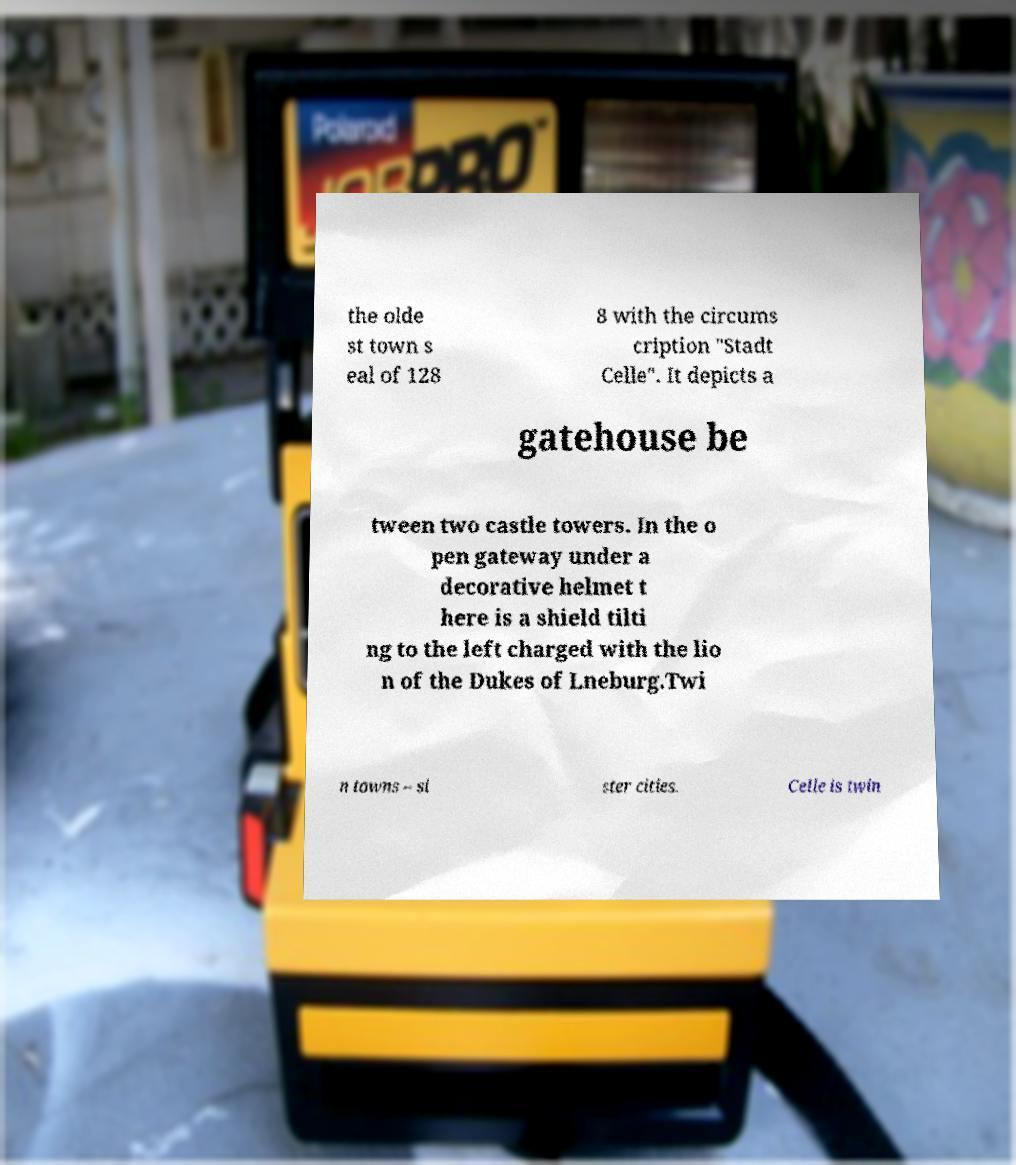For documentation purposes, I need the text within this image transcribed. Could you provide that? the olde st town s eal of 128 8 with the circums cription "Stadt Celle". It depicts a gatehouse be tween two castle towers. In the o pen gateway under a decorative helmet t here is a shield tilti ng to the left charged with the lio n of the Dukes of Lneburg.Twi n towns – si ster cities. Celle is twin 